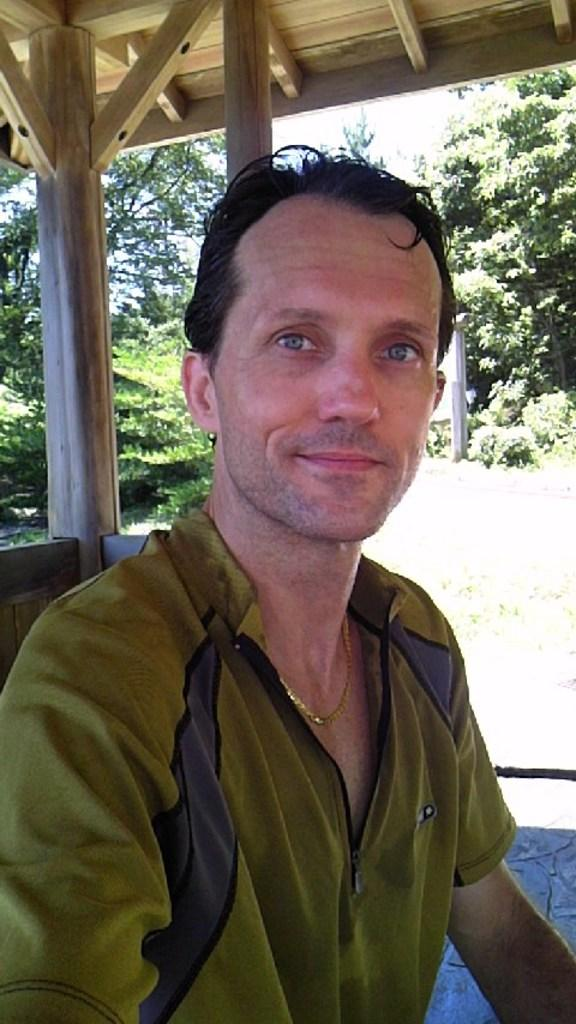Who is present in the image? There is a man in the image. What structure is visible in the image? There is a roof visible in the image. What type of material is used for the poles in the image? There are wooden poles in the image. What type of vegetation can be seen in the image? There is a group of trees in the image. How many geese are flying over the trees in the image? There are no geese present in the image; it only features a man, a roof, wooden poles, and a group of trees. 